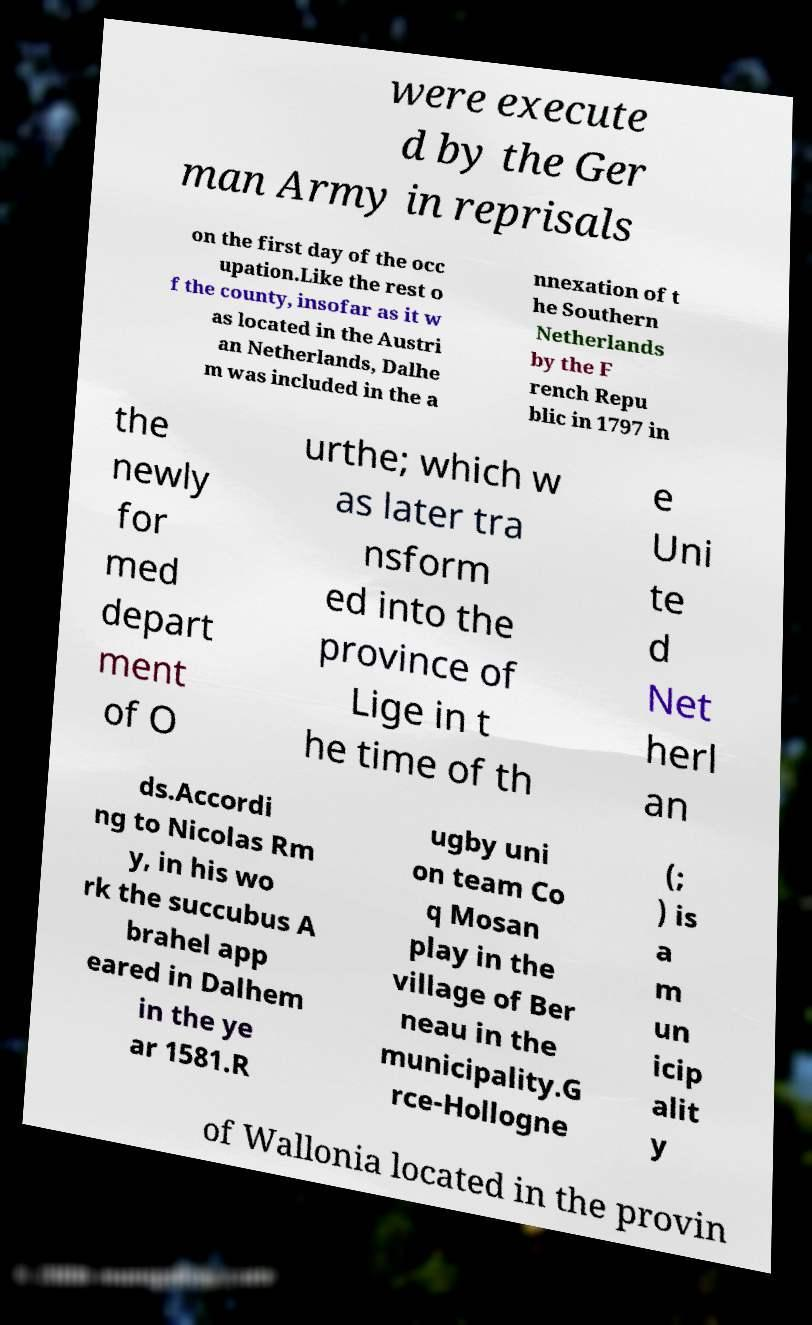I need the written content from this picture converted into text. Can you do that? were execute d by the Ger man Army in reprisals on the first day of the occ upation.Like the rest o f the county, insofar as it w as located in the Austri an Netherlands, Dalhe m was included in the a nnexation of t he Southern Netherlands by the F rench Repu blic in 1797 in the newly for med depart ment of O urthe; which w as later tra nsform ed into the province of Lige in t he time of th e Uni te d Net herl an ds.Accordi ng to Nicolas Rm y, in his wo rk the succubus A brahel app eared in Dalhem in the ye ar 1581.R ugby uni on team Co q Mosan play in the village of Ber neau in the municipality.G rce-Hollogne (; ) is a m un icip alit y of Wallonia located in the provin 